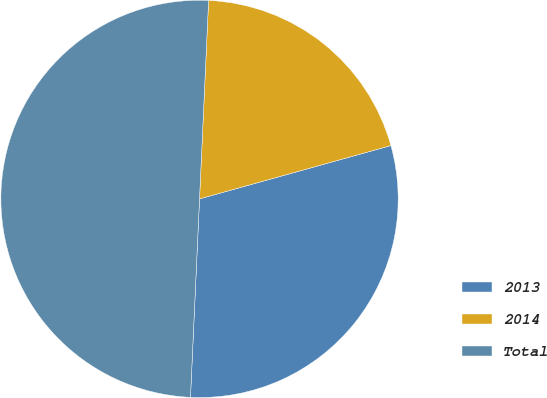Convert chart. <chart><loc_0><loc_0><loc_500><loc_500><pie_chart><fcel>2013<fcel>2014<fcel>Total<nl><fcel>30.05%<fcel>19.95%<fcel>50.0%<nl></chart> 